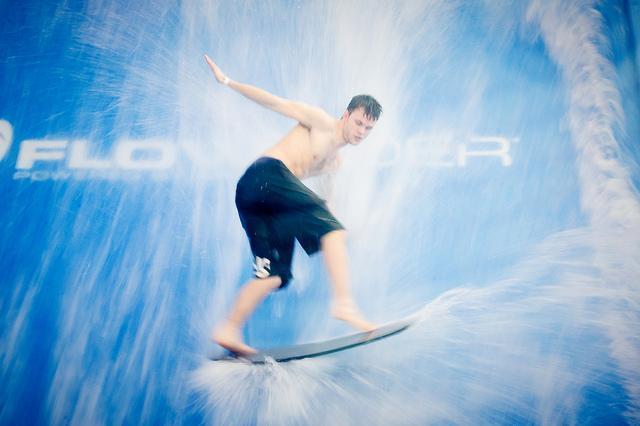How many surfboards are there?
Give a very brief answer. 1. 